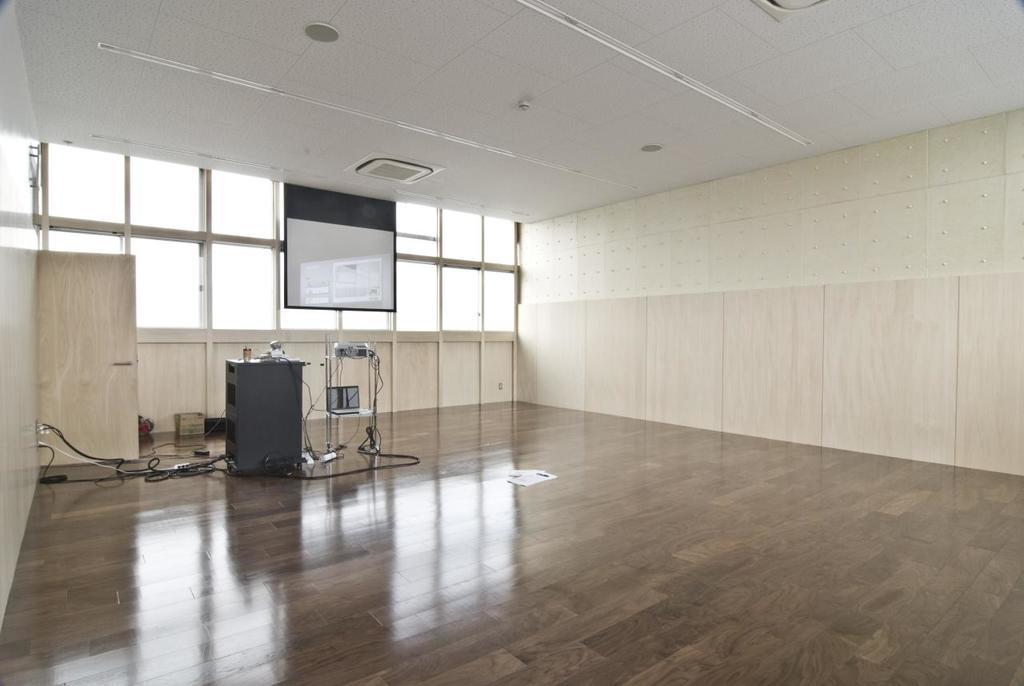Could you give a brief overview of what you see in this image? In this picture I can see there is an empty room, there is a screen at left side, a projector and there are few other objects and there are few windows and the room is empty. 